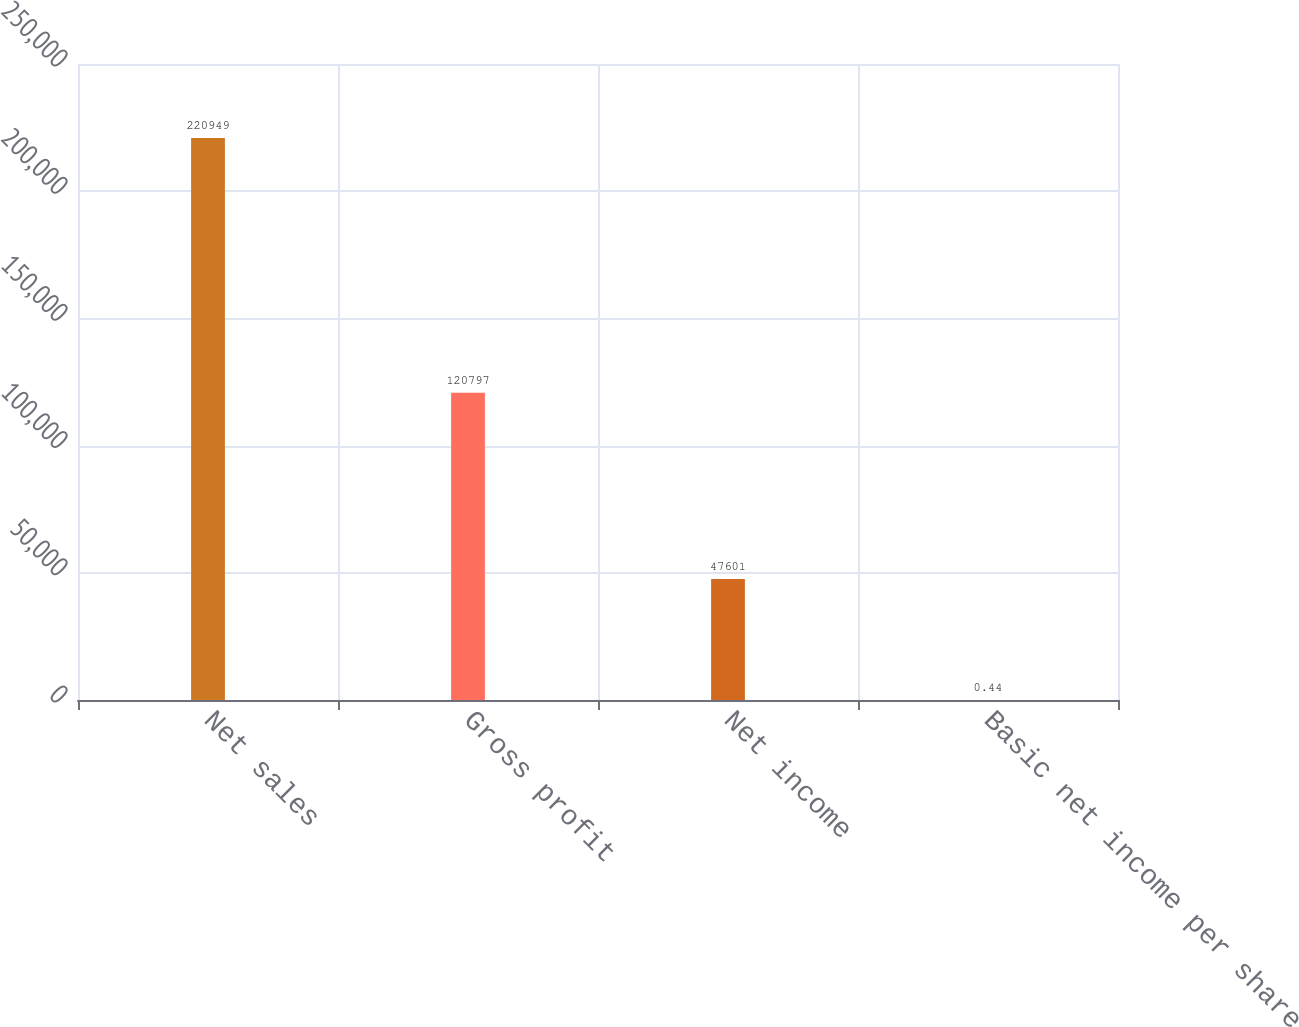Convert chart to OTSL. <chart><loc_0><loc_0><loc_500><loc_500><bar_chart><fcel>Net sales<fcel>Gross profit<fcel>Net income<fcel>Basic net income per share<nl><fcel>220949<fcel>120797<fcel>47601<fcel>0.44<nl></chart> 